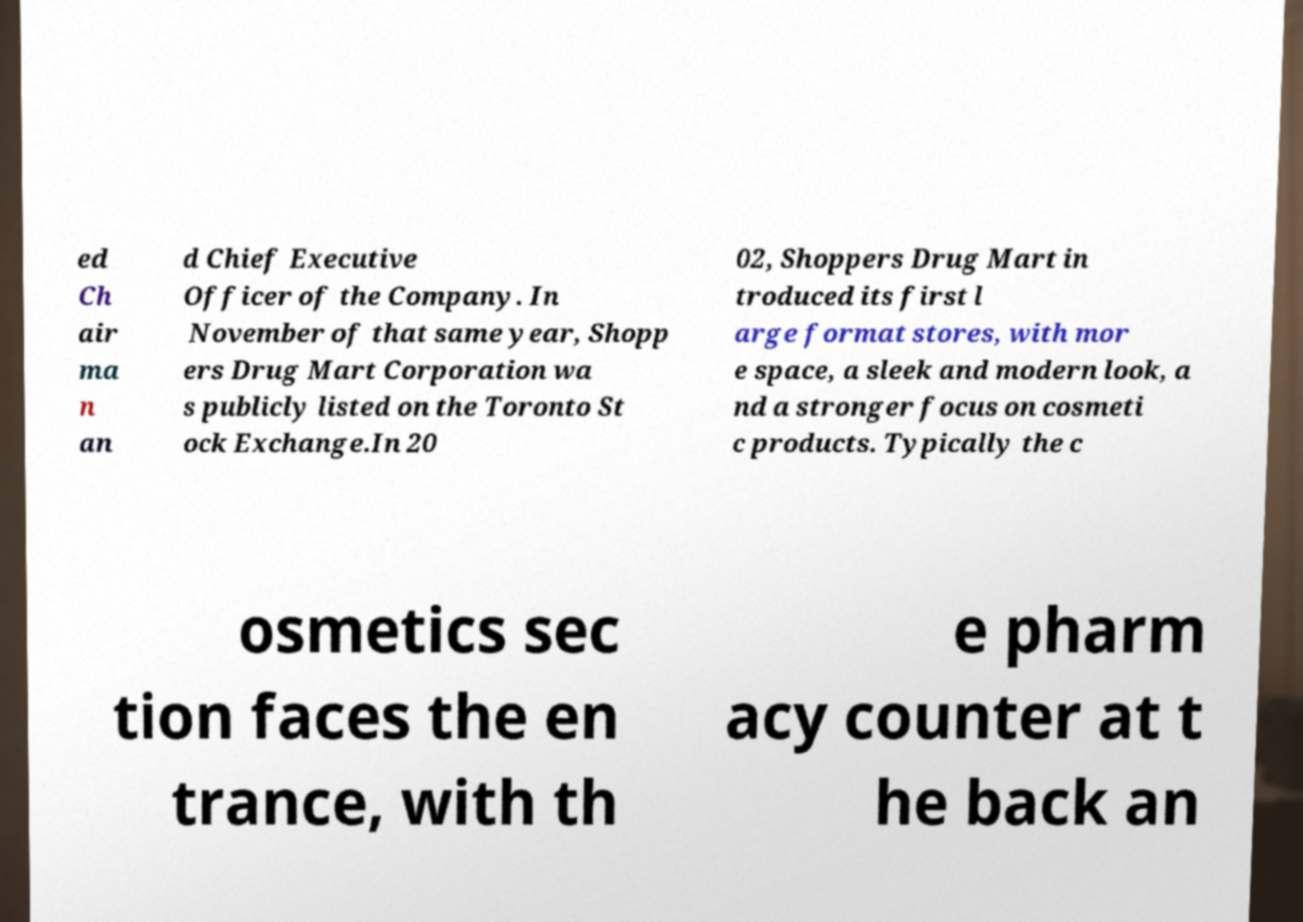I need the written content from this picture converted into text. Can you do that? ed Ch air ma n an d Chief Executive Officer of the Company. In November of that same year, Shopp ers Drug Mart Corporation wa s publicly listed on the Toronto St ock Exchange.In 20 02, Shoppers Drug Mart in troduced its first l arge format stores, with mor e space, a sleek and modern look, a nd a stronger focus on cosmeti c products. Typically the c osmetics sec tion faces the en trance, with th e pharm acy counter at t he back an 